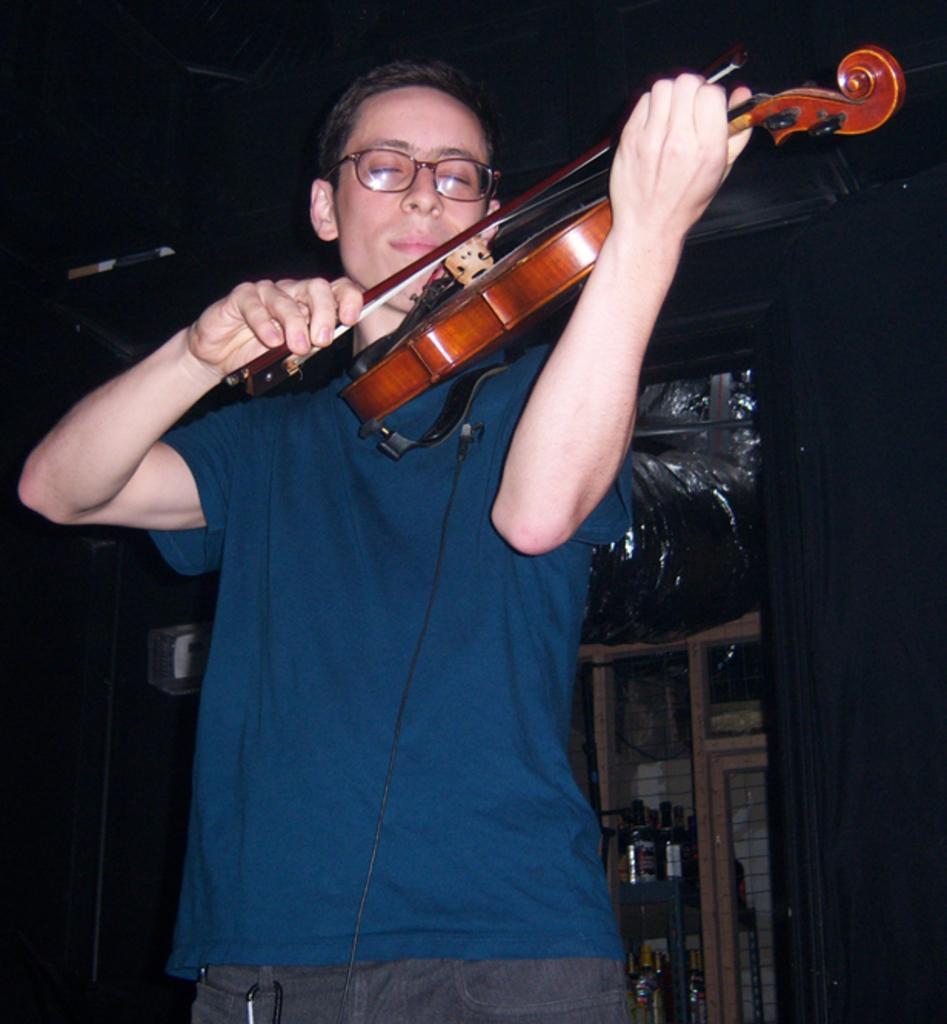Could you give a brief overview of what you see in this image? This is the picture of a boy wearing blue shirt and holding a guitar and behind there is a shelf on which some bottles are placed. 